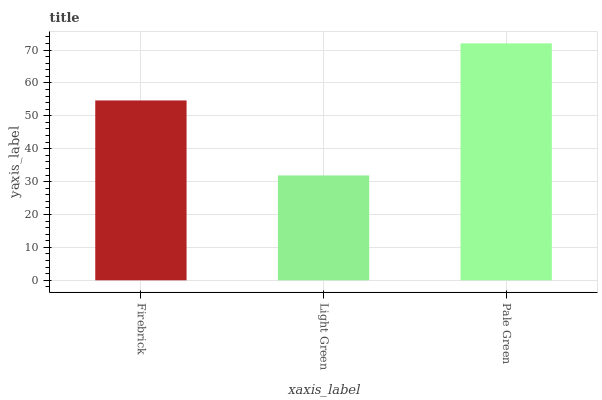Is Pale Green the minimum?
Answer yes or no. No. Is Light Green the maximum?
Answer yes or no. No. Is Pale Green greater than Light Green?
Answer yes or no. Yes. Is Light Green less than Pale Green?
Answer yes or no. Yes. Is Light Green greater than Pale Green?
Answer yes or no. No. Is Pale Green less than Light Green?
Answer yes or no. No. Is Firebrick the high median?
Answer yes or no. Yes. Is Firebrick the low median?
Answer yes or no. Yes. Is Light Green the high median?
Answer yes or no. No. Is Pale Green the low median?
Answer yes or no. No. 